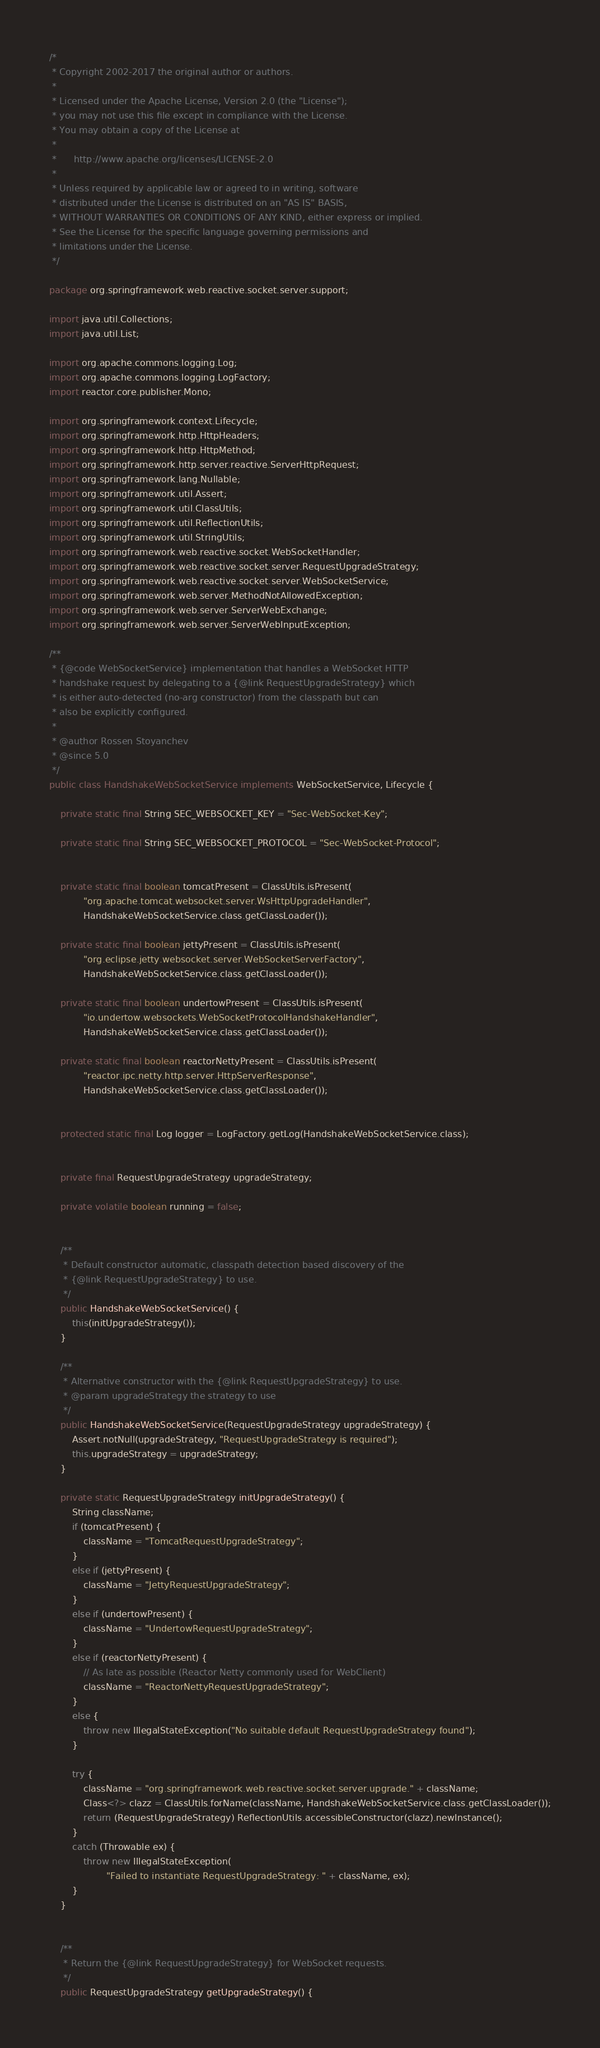<code> <loc_0><loc_0><loc_500><loc_500><_Java_>/*
 * Copyright 2002-2017 the original author or authors.
 *
 * Licensed under the Apache License, Version 2.0 (the "License");
 * you may not use this file except in compliance with the License.
 * You may obtain a copy of the License at
 *
 *      http://www.apache.org/licenses/LICENSE-2.0
 *
 * Unless required by applicable law or agreed to in writing, software
 * distributed under the License is distributed on an "AS IS" BASIS,
 * WITHOUT WARRANTIES OR CONDITIONS OF ANY KIND, either express or implied.
 * See the License for the specific language governing permissions and
 * limitations under the License.
 */

package org.springframework.web.reactive.socket.server.support;

import java.util.Collections;
import java.util.List;

import org.apache.commons.logging.Log;
import org.apache.commons.logging.LogFactory;
import reactor.core.publisher.Mono;

import org.springframework.context.Lifecycle;
import org.springframework.http.HttpHeaders;
import org.springframework.http.HttpMethod;
import org.springframework.http.server.reactive.ServerHttpRequest;
import org.springframework.lang.Nullable;
import org.springframework.util.Assert;
import org.springframework.util.ClassUtils;
import org.springframework.util.ReflectionUtils;
import org.springframework.util.StringUtils;
import org.springframework.web.reactive.socket.WebSocketHandler;
import org.springframework.web.reactive.socket.server.RequestUpgradeStrategy;
import org.springframework.web.reactive.socket.server.WebSocketService;
import org.springframework.web.server.MethodNotAllowedException;
import org.springframework.web.server.ServerWebExchange;
import org.springframework.web.server.ServerWebInputException;

/**
 * {@code WebSocketService} implementation that handles a WebSocket HTTP
 * handshake request by delegating to a {@link RequestUpgradeStrategy} which
 * is either auto-detected (no-arg constructor) from the classpath but can
 * also be explicitly configured.
 *
 * @author Rossen Stoyanchev
 * @since 5.0
 */
public class HandshakeWebSocketService implements WebSocketService, Lifecycle {

	private static final String SEC_WEBSOCKET_KEY = "Sec-WebSocket-Key";

	private static final String SEC_WEBSOCKET_PROTOCOL = "Sec-WebSocket-Protocol";


	private static final boolean tomcatPresent = ClassUtils.isPresent(
			"org.apache.tomcat.websocket.server.WsHttpUpgradeHandler",
			HandshakeWebSocketService.class.getClassLoader());

	private static final boolean jettyPresent = ClassUtils.isPresent(
			"org.eclipse.jetty.websocket.server.WebSocketServerFactory",
			HandshakeWebSocketService.class.getClassLoader());

	private static final boolean undertowPresent = ClassUtils.isPresent(
			"io.undertow.websockets.WebSocketProtocolHandshakeHandler",
			HandshakeWebSocketService.class.getClassLoader());

	private static final boolean reactorNettyPresent = ClassUtils.isPresent(
			"reactor.ipc.netty.http.server.HttpServerResponse",
			HandshakeWebSocketService.class.getClassLoader());


	protected static final Log logger = LogFactory.getLog(HandshakeWebSocketService.class);


	private final RequestUpgradeStrategy upgradeStrategy;

	private volatile boolean running = false;


	/**
	 * Default constructor automatic, classpath detection based discovery of the
	 * {@link RequestUpgradeStrategy} to use.
	 */
	public HandshakeWebSocketService() {
		this(initUpgradeStrategy());
	}

	/**
	 * Alternative constructor with the {@link RequestUpgradeStrategy} to use.
	 * @param upgradeStrategy the strategy to use
	 */
	public HandshakeWebSocketService(RequestUpgradeStrategy upgradeStrategy) {
		Assert.notNull(upgradeStrategy, "RequestUpgradeStrategy is required");
		this.upgradeStrategy = upgradeStrategy;
	}

	private static RequestUpgradeStrategy initUpgradeStrategy() {
		String className;
		if (tomcatPresent) {
			className = "TomcatRequestUpgradeStrategy";
		}
		else if (jettyPresent) {
			className = "JettyRequestUpgradeStrategy";
		}
		else if (undertowPresent) {
			className = "UndertowRequestUpgradeStrategy";
		}
		else if (reactorNettyPresent) {
			// As late as possible (Reactor Netty commonly used for WebClient)
			className = "ReactorNettyRequestUpgradeStrategy";
		}
		else {
			throw new IllegalStateException("No suitable default RequestUpgradeStrategy found");
		}

		try {
			className = "org.springframework.web.reactive.socket.server.upgrade." + className;
			Class<?> clazz = ClassUtils.forName(className, HandshakeWebSocketService.class.getClassLoader());
			return (RequestUpgradeStrategy) ReflectionUtils.accessibleConstructor(clazz).newInstance();
		}
		catch (Throwable ex) {
			throw new IllegalStateException(
					"Failed to instantiate RequestUpgradeStrategy: " + className, ex);
		}
	}


	/**
	 * Return the {@link RequestUpgradeStrategy} for WebSocket requests.
	 */
	public RequestUpgradeStrategy getUpgradeStrategy() {</code> 